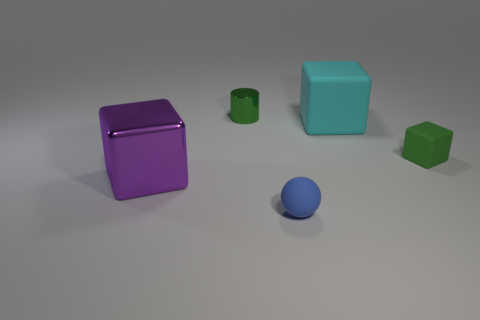Subtract all matte blocks. How many blocks are left? 1 Add 3 cyan things. How many objects exist? 8 Subtract all cubes. How many objects are left? 2 Subtract 0 purple balls. How many objects are left? 5 Subtract all large cyan rubber cubes. Subtract all purple things. How many objects are left? 3 Add 5 green objects. How many green objects are left? 7 Add 2 tiny cyan rubber cubes. How many tiny cyan rubber cubes exist? 2 